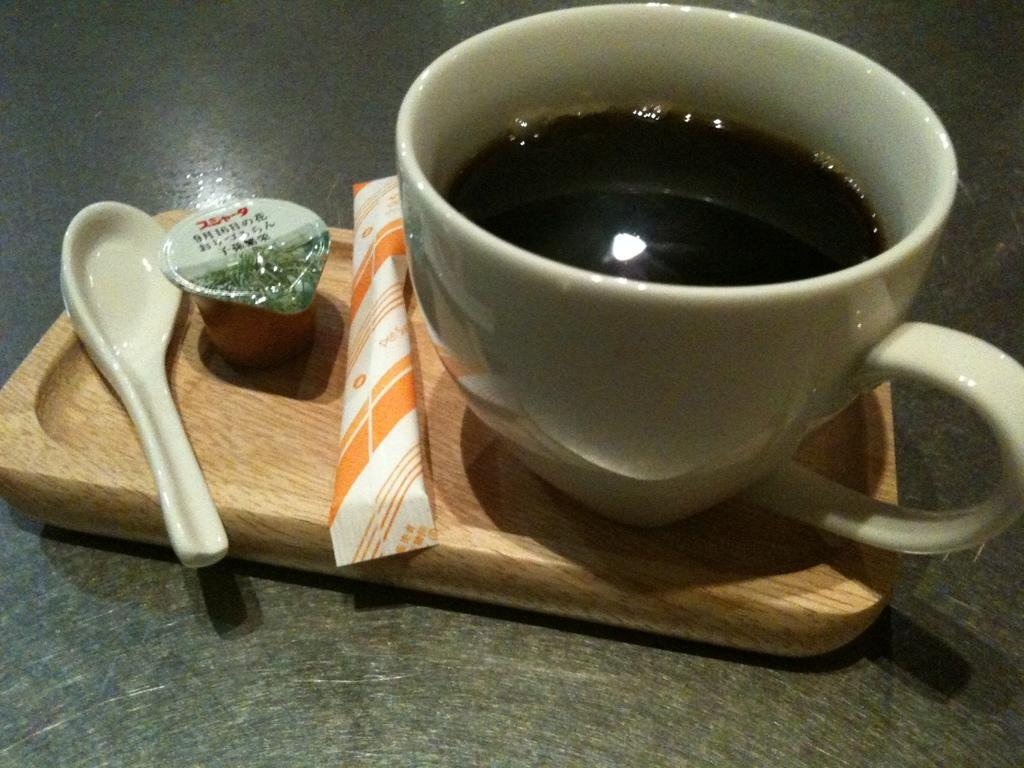What is present on the wooden tray in the image? The tea cup, spoon, and milk sachet are on the wooden tray in the image. What is the wooden tray placed on in the image? The wooden tray is on a table in the image. What is used for stirring in the image? There is a spoon in the image. What is used for adding milk in the image? There is a milk sachet in the image. How many ducks are present in the image? There are no ducks present in the image. What type of pigs can be seen in the image? There are no pigs present in the image. 